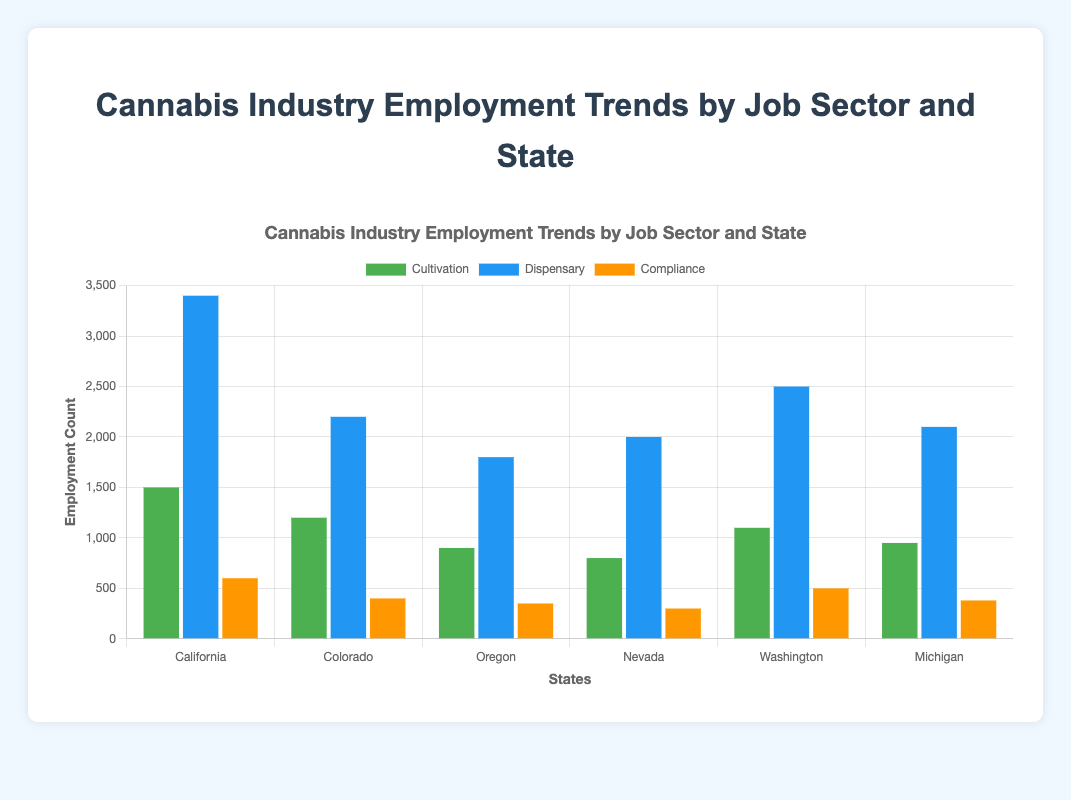Which state has the highest employment count in the cannabis dispensary sector? To answer this question, look at the height of the blue bars (representing the dispensary sector) in the chart and identify the tallest one. California’s blue bar is the tallest among all states.
Answer: California What is the total employment count for the compliance sector across all states? Sum the employment counts for the compliance sector across all states: California (600), Colorado (400), Oregon (350), Nevada (300), Washington (500), and Michigan (380). Adding these gives 600 + 400 + 350 + 300 + 500 + 380 = 2530.
Answer: 2530 In which state does the cultivation sector have the fewest employees? Look for the green bars (representing the cultivation sector) and identify the shortest one. Nevada's green bar is the shortest, indicating it has the fewest employees in cultivation.
Answer: Nevada How does the employment count for budtenders in Oregon compare to that in Nevada? Compare the blue bars for the dispensary sector in Oregon and Nevada. Oregon has 1800 employees, and Nevada has 2000 employees in this sector. Hence, Nevada has more budtenders than Oregon.
Answer: Nevada What's the combined employment count of cultivation and dispensary sectors in Colorado? Sum the employment counts of both sectors in Colorado: Cultivation (1200) + Dispensary (2200). So, 1200 + 2200 = 3400.
Answer: 3400 Which state has the highest overall employment count across all job sectors? Calculate the total employment count for each state by summing the values of all sectors and compare. California has the highest: Cultivation (1500) + Dispensary (3400) + Compliance (600) = 5500.
Answer: California How many more cultivation employees are there in California than in Oregon? Find the difference in cultivation employment counts between California and Oregon: 1500 (California) - 900 (Oregon) = 600.
Answer: 600 Which job sector in Michigan has the closest employment count to the compliance sector in Washington? Compare the employment counts of different sectors in Michigan with the compliance sector in Washington (500). In Michigan: Cultivation (950), Dispensary (2100), Compliance (380). Compliance sector in Michigan (380) is closest to Washington compliance sector (500).
Answer: Compliance Which visual attribute indicates the employment count for each sector in the chart? The height of the bars indicates the employment count for each sector. Taller bars represent higher employment counts.
Answer: Height of the bars 